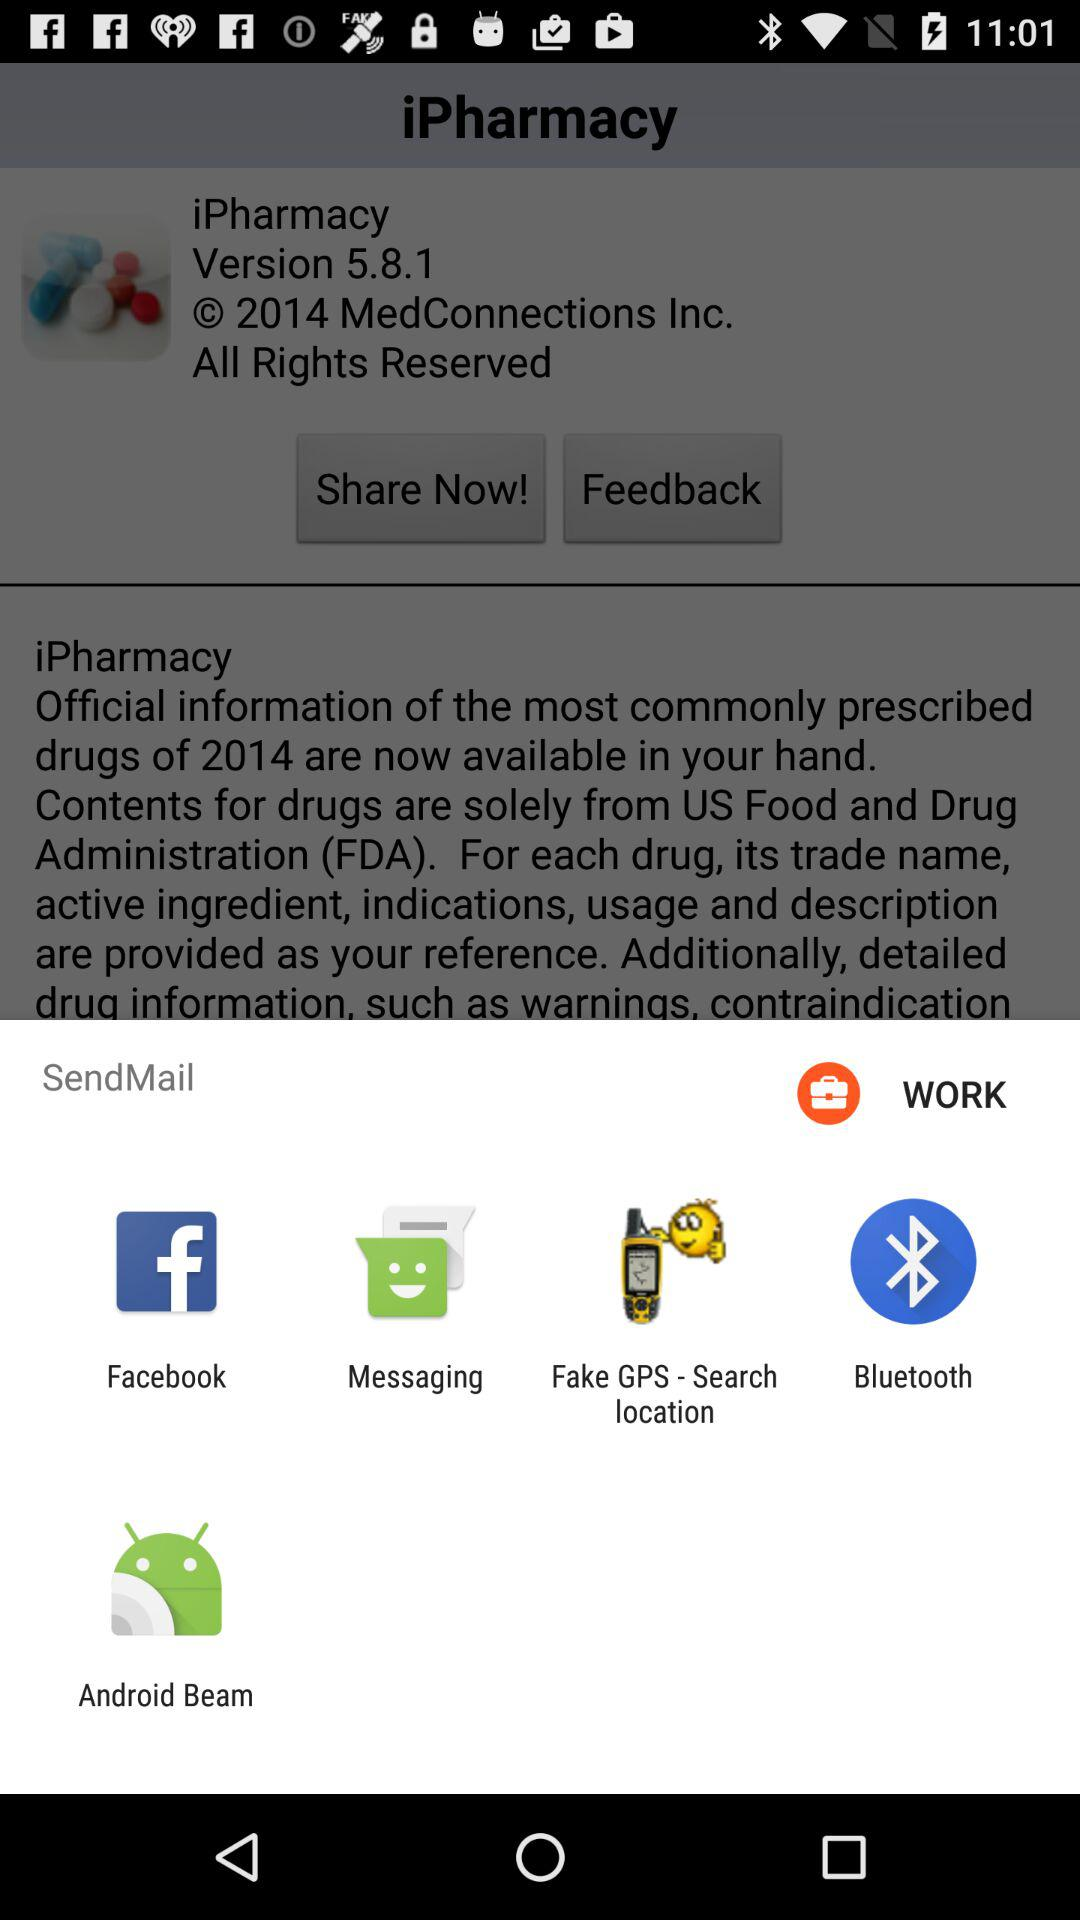What is the version of the application? The version of the application is 5.8.1. 